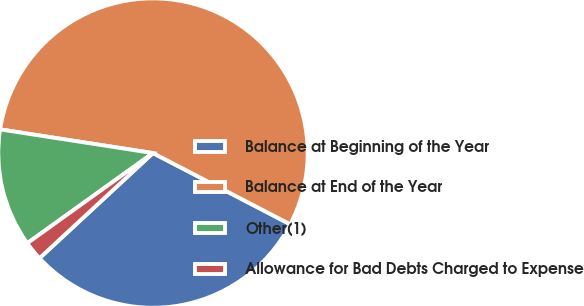Convert chart to OTSL. <chart><loc_0><loc_0><loc_500><loc_500><pie_chart><fcel>Balance at Beginning of the Year<fcel>Balance at End of the Year<fcel>Other(1)<fcel>Allowance for Bad Debts Charged to Expense<nl><fcel>30.49%<fcel>55.18%<fcel>12.35%<fcel>1.99%<nl></chart> 